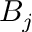<formula> <loc_0><loc_0><loc_500><loc_500>B _ { j }</formula> 